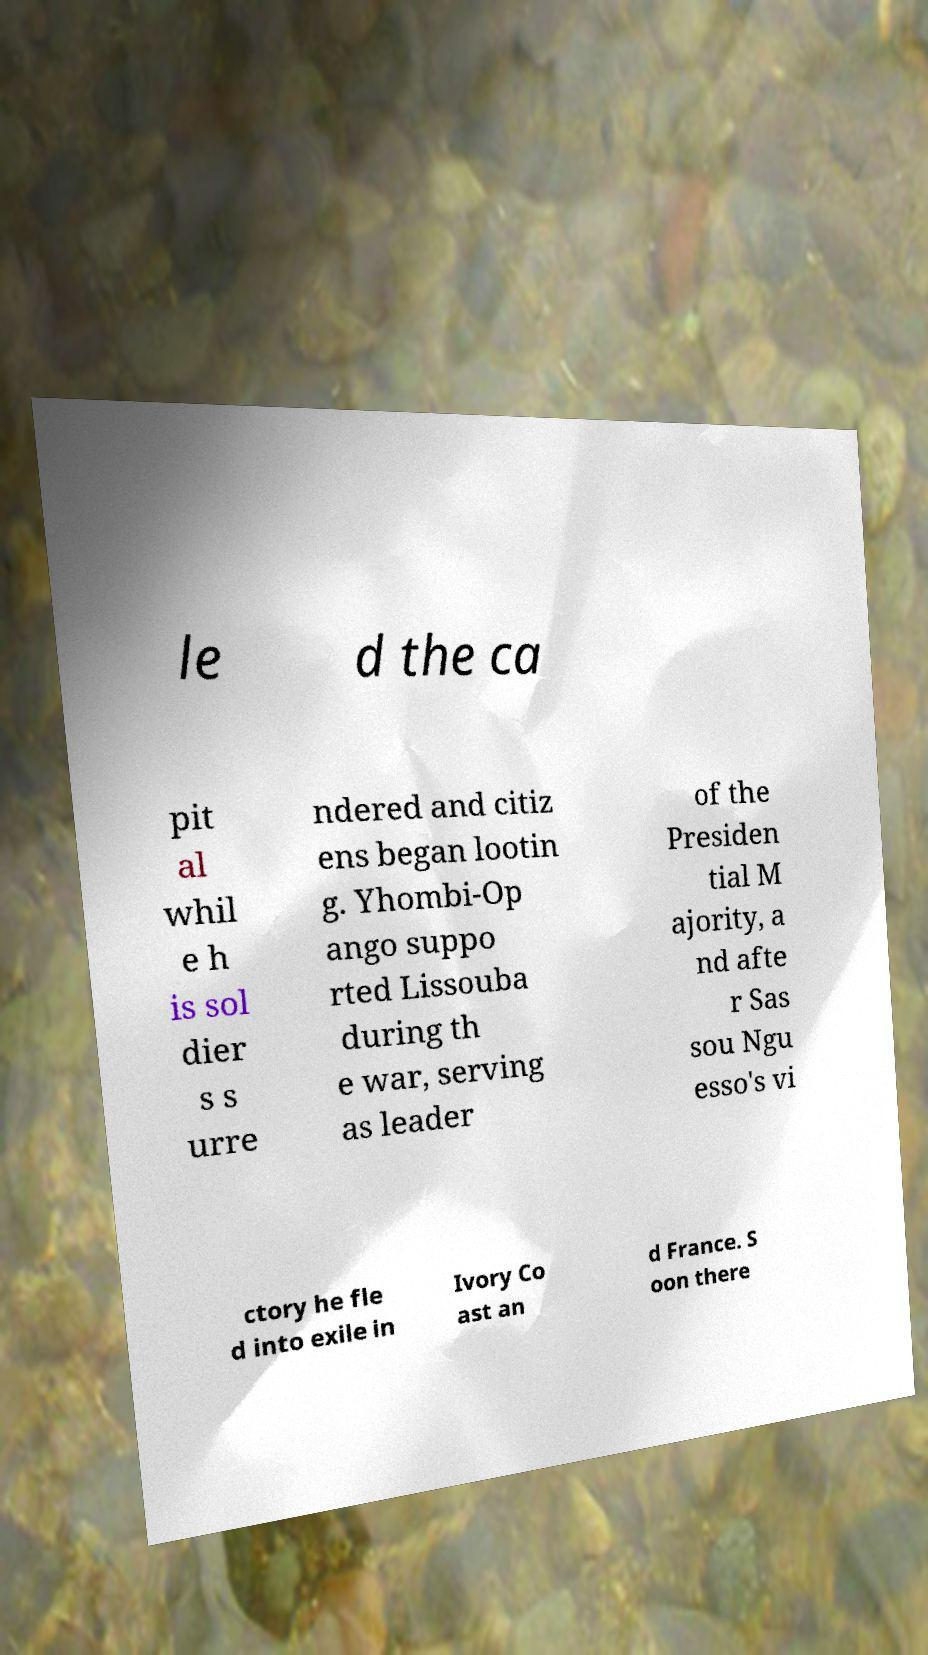For documentation purposes, I need the text within this image transcribed. Could you provide that? le d the ca pit al whil e h is sol dier s s urre ndered and citiz ens began lootin g. Yhombi-Op ango suppo rted Lissouba during th e war, serving as leader of the Presiden tial M ajority, a nd afte r Sas sou Ngu esso's vi ctory he fle d into exile in Ivory Co ast an d France. S oon there 